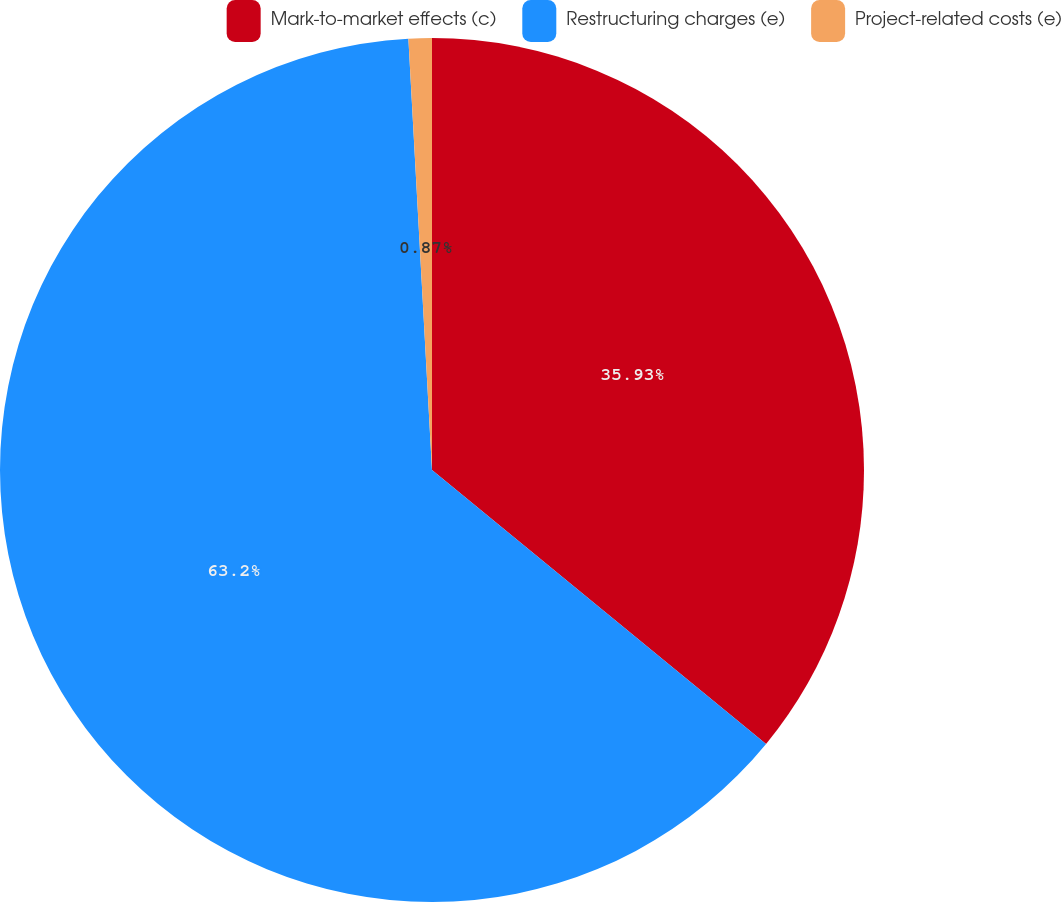<chart> <loc_0><loc_0><loc_500><loc_500><pie_chart><fcel>Mark-to-market effects (c)<fcel>Restructuring charges (e)<fcel>Project-related costs (e)<nl><fcel>35.93%<fcel>63.2%<fcel>0.87%<nl></chart> 